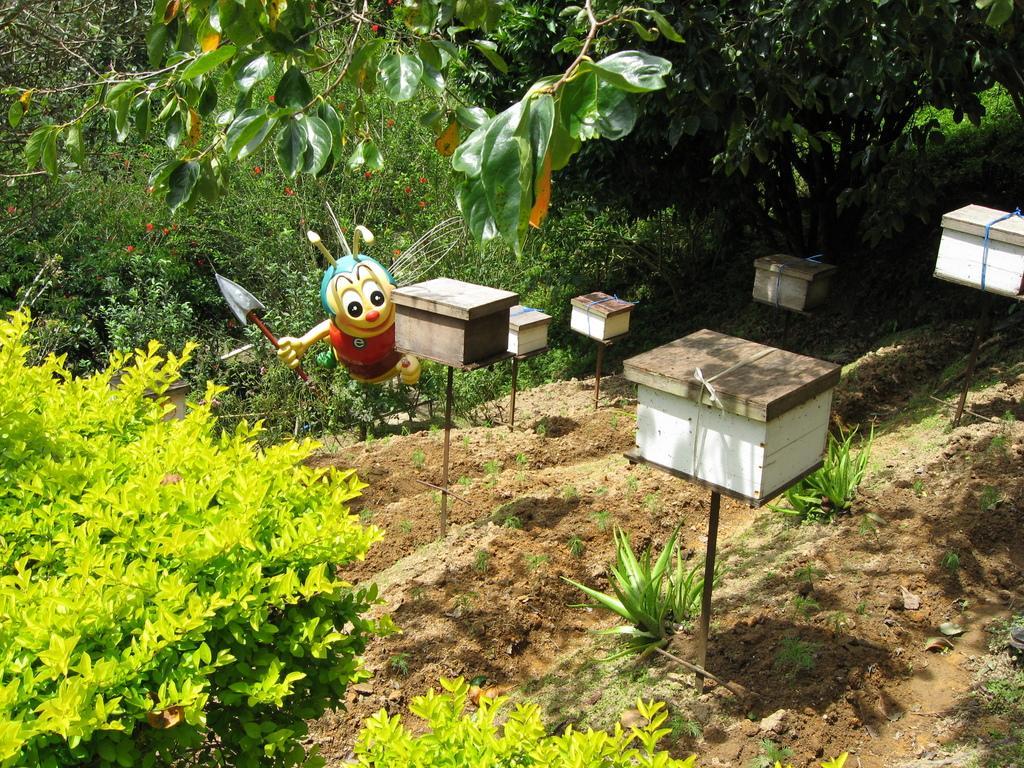Could you give a brief overview of what you see in this image? In the image there are stands with boxes. On the ground there are few plants. And in the image there are many trees. And also there is a honey bee statue. 